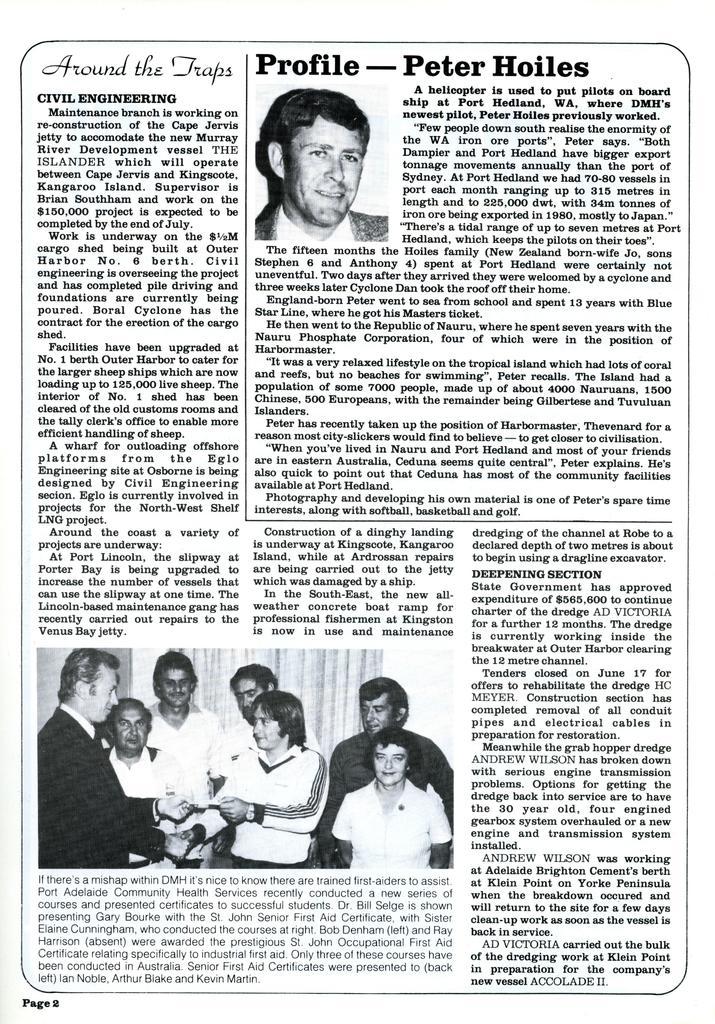Could you give a brief overview of what you see in this image? In this image we can see a paper and in the paper we can see the text and also human images. We can also see the page number at the bottom. 